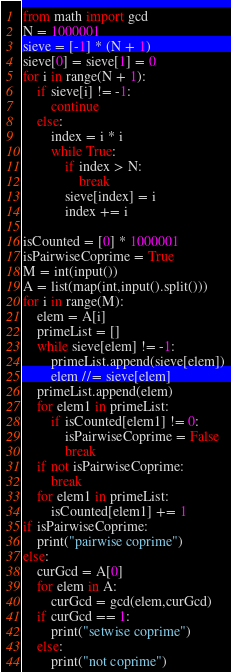Convert code to text. <code><loc_0><loc_0><loc_500><loc_500><_Python_>from math import gcd
N = 1000001
sieve = [-1] * (N + 1)
sieve[0] = sieve[1] = 0
for i in range(N + 1):
    if sieve[i] != -1:
        continue
    else:
        index = i * i
        while True:
            if index > N:
                break
            sieve[index] = i
            index += i

isCounted = [0] * 1000001
isPairwiseCoprime = True
M = int(input())
A = list(map(int,input().split()))
for i in range(M):
    elem = A[i]
    primeList = []
    while sieve[elem] != -1:
        primeList.append(sieve[elem])
        elem //= sieve[elem]
    primeList.append(elem)
    for elem1 in primeList:
        if isCounted[elem1] != 0:
            isPairwiseCoprime = False
            break
    if not isPairwiseCoprime:
        break
    for elem1 in primeList:
        isCounted[elem1] += 1
if isPairwiseCoprime:
    print("pairwise coprime")
else:
    curGcd = A[0]
    for elem in A:
        curGcd = gcd(elem,curGcd)
    if curGcd == 1:
        print("setwise coprime")
    else:
        print("not coprime")
</code> 